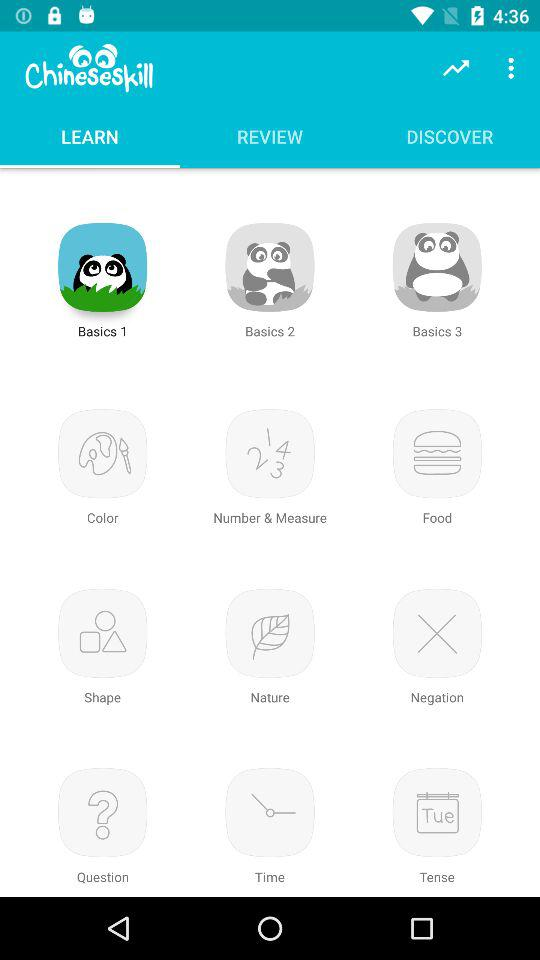What is the selected learning type for Chinese learning skills? The selected learning type is "Basics 1". 